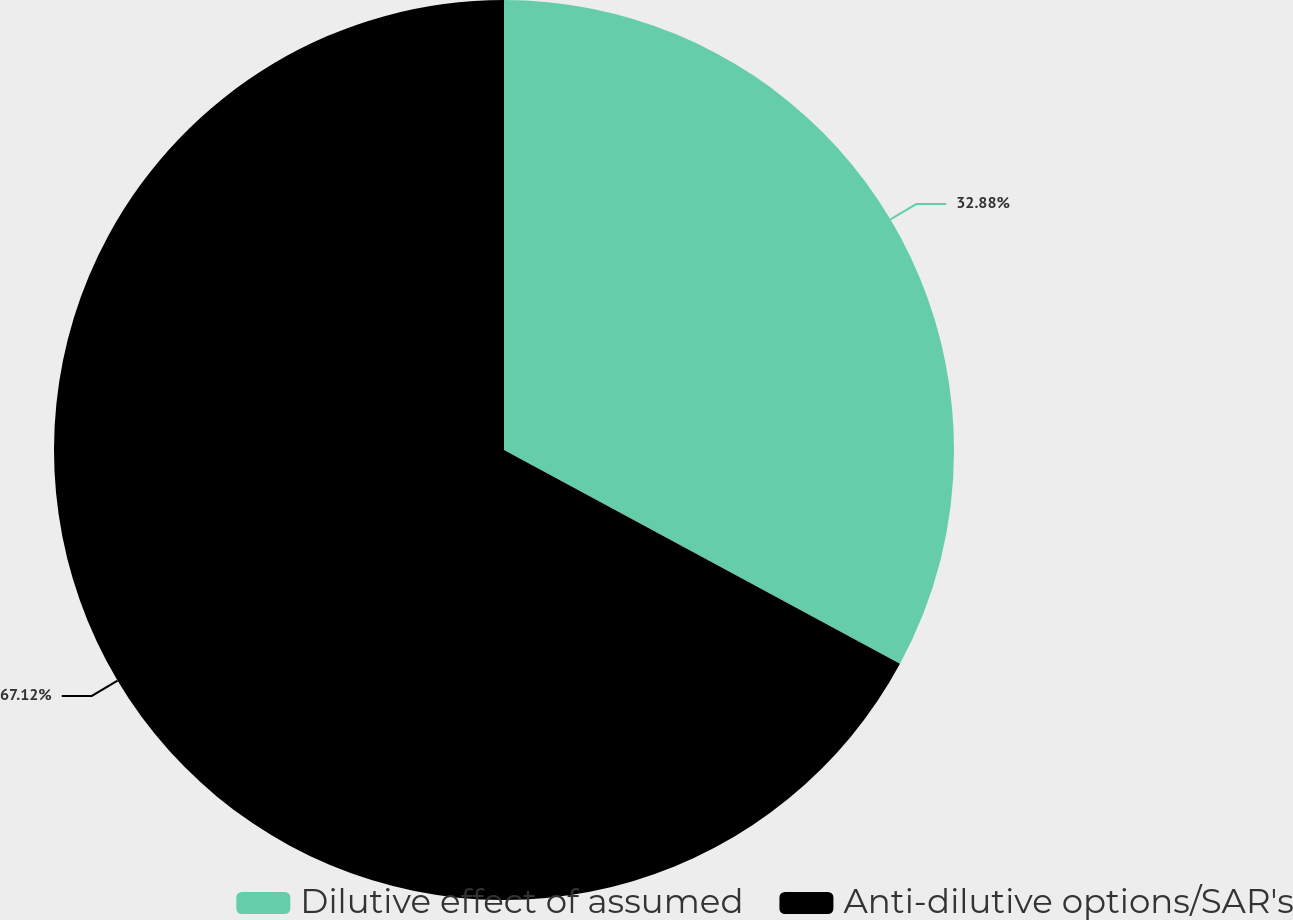Convert chart to OTSL. <chart><loc_0><loc_0><loc_500><loc_500><pie_chart><fcel>Dilutive effect of assumed<fcel>Anti-dilutive options/SAR's<nl><fcel>32.88%<fcel>67.12%<nl></chart> 